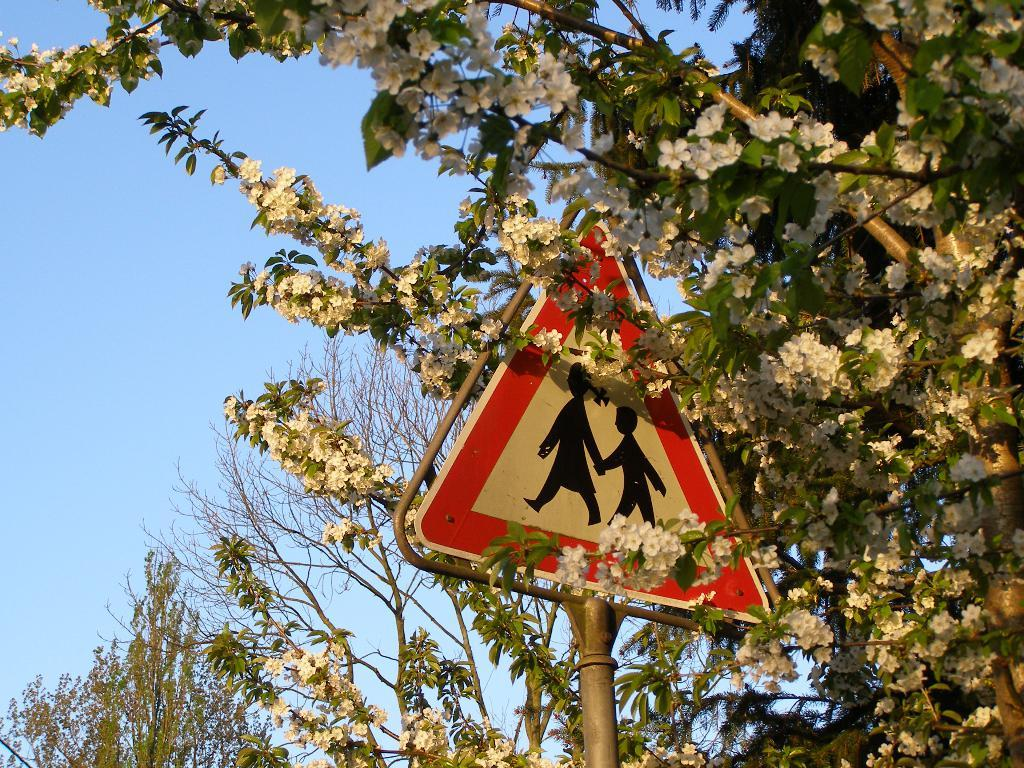What is attached to the pole in the image? There is a board attached to the pole in the image. What can be seen beside the pole in the image? There is a tree with many flowers beside the pole in the image. What is visible in the background of the image? The sky is visible in the image. What type of reaction can be seen on the robin's face in the image? There is no robin present in the image; it only features a pole with a board, a tree with flowers, and the sky. 